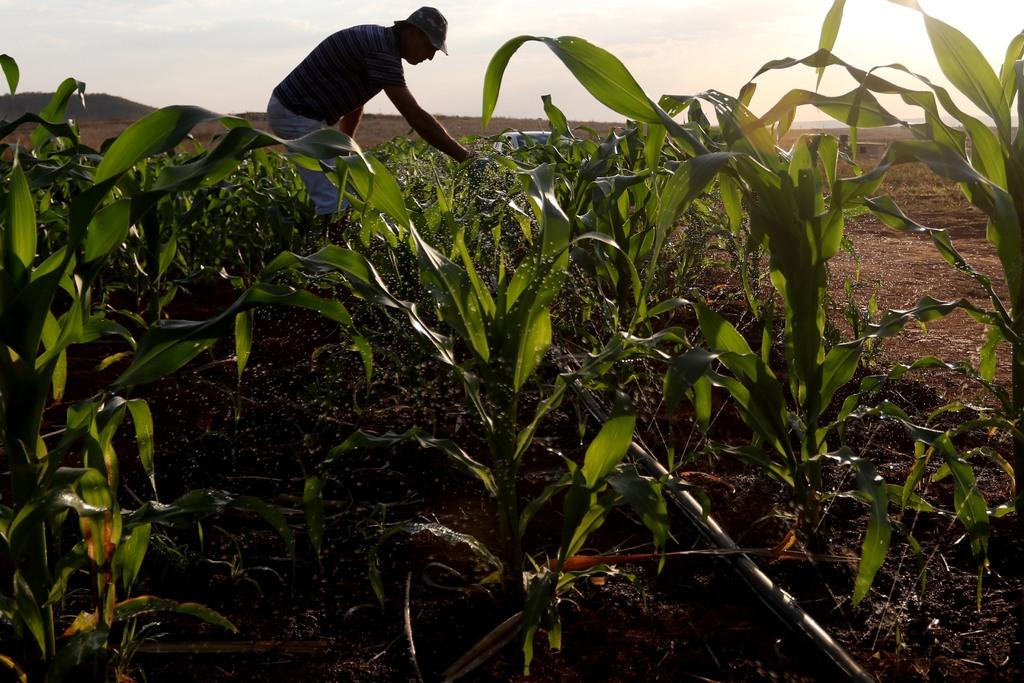Who is present in the image? There is a man in the image. What is the man doing in the image? The man is standing and touching plants with his hand. What is the man wearing on his head? The man is wearing a cap. What is the condition of the sky in the image? The sky is cloudy in the image. Can you see a river flowing in the background of the image? There is no river visible in the image. What type of art is the man creating with the plants in the image? The image does not show the man creating any art with the plants. 